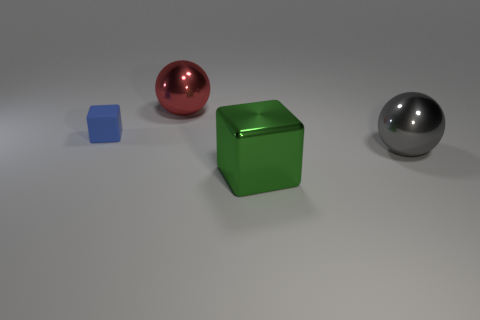What number of objects are yellow matte blocks or green metallic blocks?
Ensure brevity in your answer.  1. Do the gray shiny sphere and the block behind the big green cube have the same size?
Your response must be concise. No. The thing that is in front of the big metallic sphere that is in front of the cube on the left side of the large red metal ball is what color?
Offer a terse response. Green. What color is the tiny cube?
Provide a succinct answer. Blue. Are there more large metal spheres to the left of the big green object than gray metal things to the left of the tiny rubber thing?
Your answer should be compact. Yes. There is a large red thing; does it have the same shape as the large green shiny thing to the right of the matte cube?
Your answer should be very brief. No. There is a sphere behind the tiny matte object; is it the same size as the cube that is left of the shiny block?
Ensure brevity in your answer.  No. Are there any large red shiny things that are behind the shiny ball in front of the metal ball behind the matte thing?
Give a very brief answer. Yes. Are there fewer objects in front of the large gray shiny object than things that are behind the green object?
Provide a succinct answer. Yes. There is a red object that is the same material as the big gray thing; what is its shape?
Give a very brief answer. Sphere. 